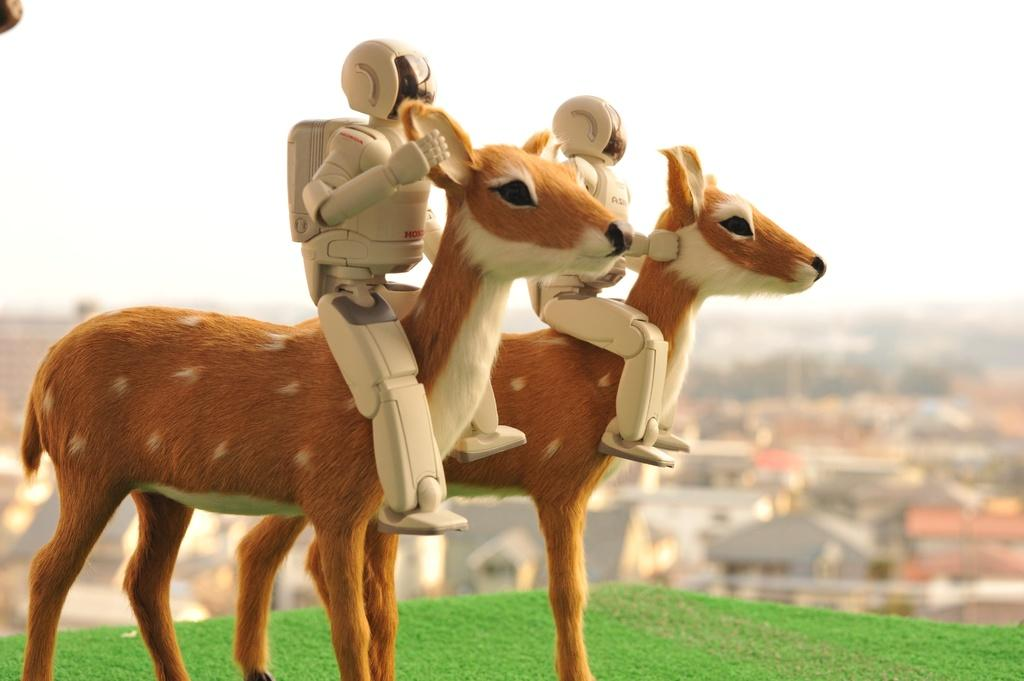What type of toys are present in the image? There are toy robots and a toy deer in the image. What is the color of the grass at the bottom of the image? The bottom of the image appears to be green grass. What can be seen in the background of the image? There are houses in the background of the image. How would you describe the appearance of the background in the image? The background of the image is blurred. What type of stove can be seen in the image? There is no stove present in the image. What message of peace is conveyed by the toy robots and deer in the image? The image does not convey a message of peace; it simply depicts toy robots and a toy deer. 